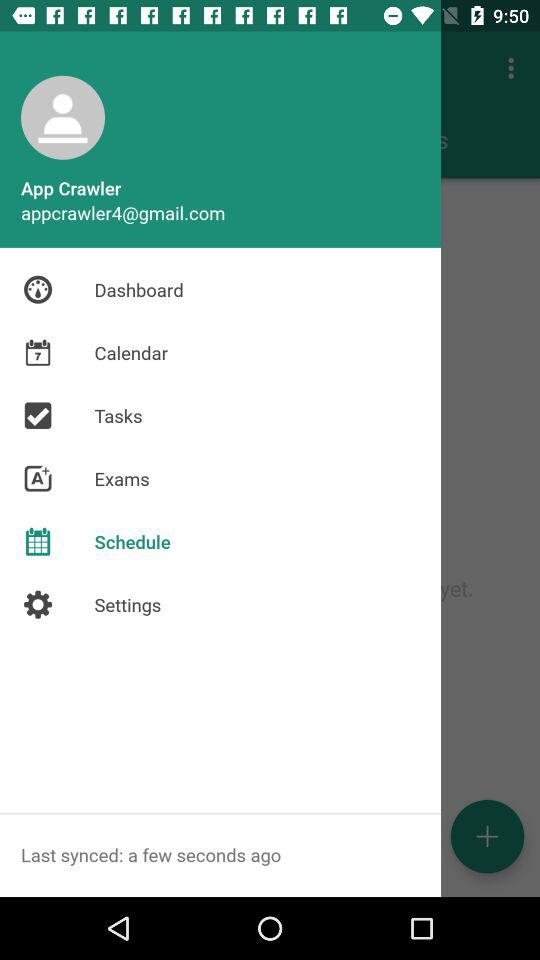How many seconds ago was the last synced? The last sync was a few seconds ago. 